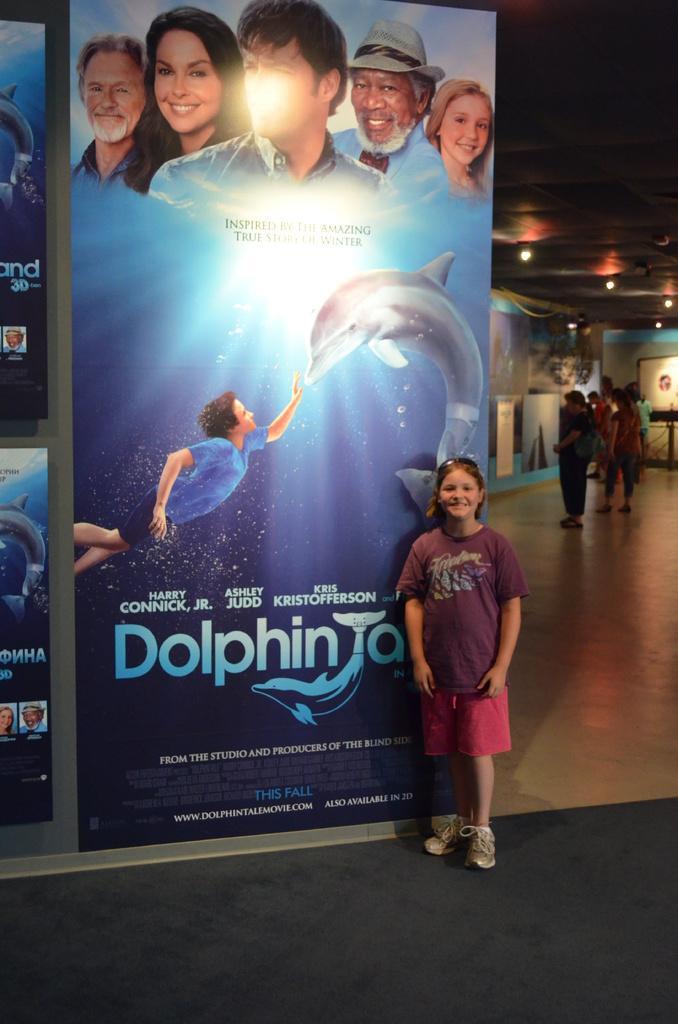Describe this image in one or two sentences. This is a person standing. This looks like a hoarding. I can see group of people standing. These are the posters attached to the wall. These are the ceiling lights. This person wore a T-shirt, short and shoes. 